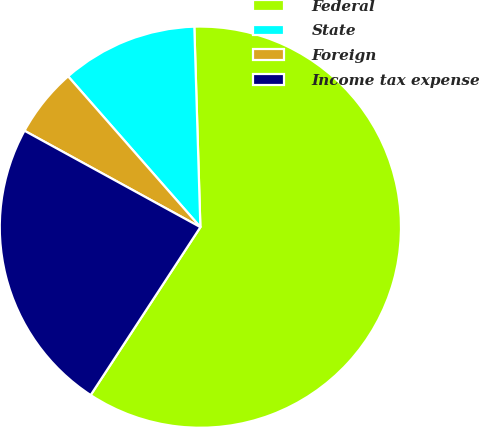<chart> <loc_0><loc_0><loc_500><loc_500><pie_chart><fcel>Federal<fcel>State<fcel>Foreign<fcel>Income tax expense<nl><fcel>59.69%<fcel>10.98%<fcel>5.56%<fcel>23.77%<nl></chart> 